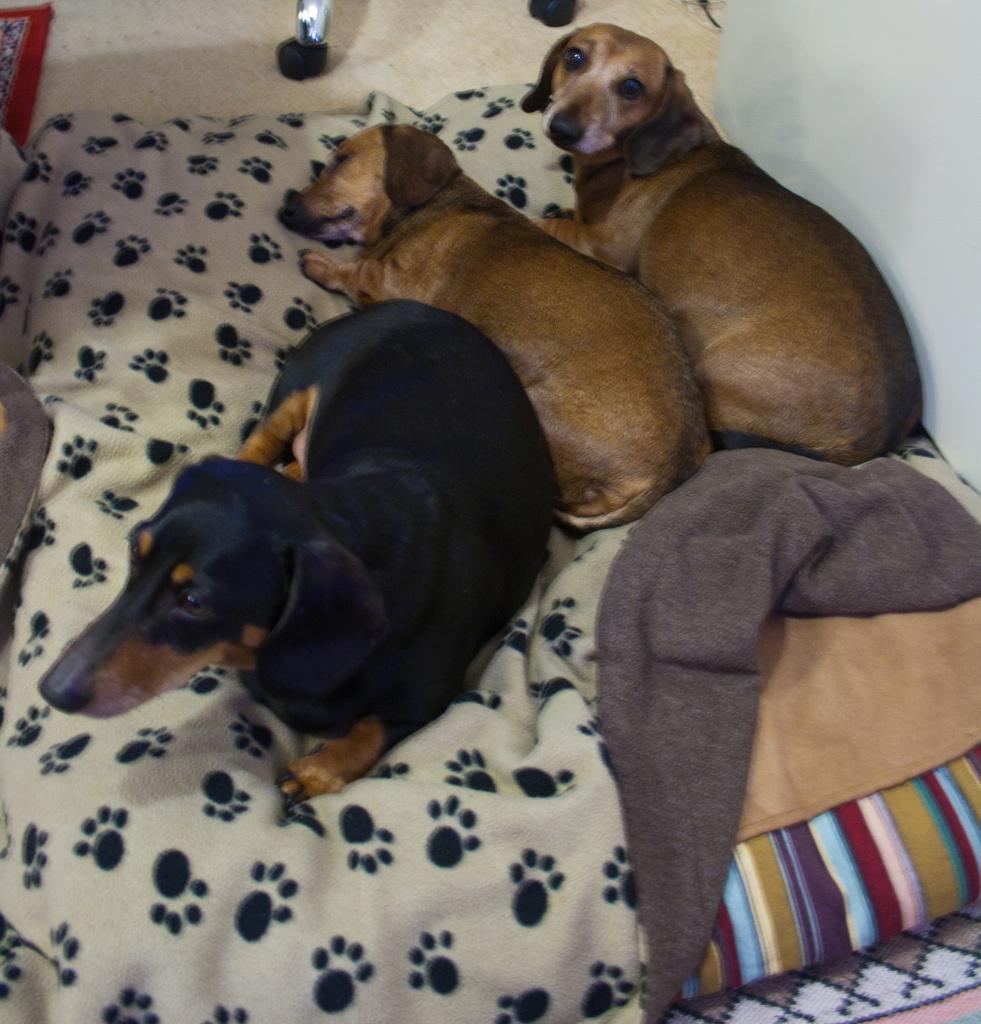Describe this image in one or two sentences. In this image, we can see dogs on the bed. 